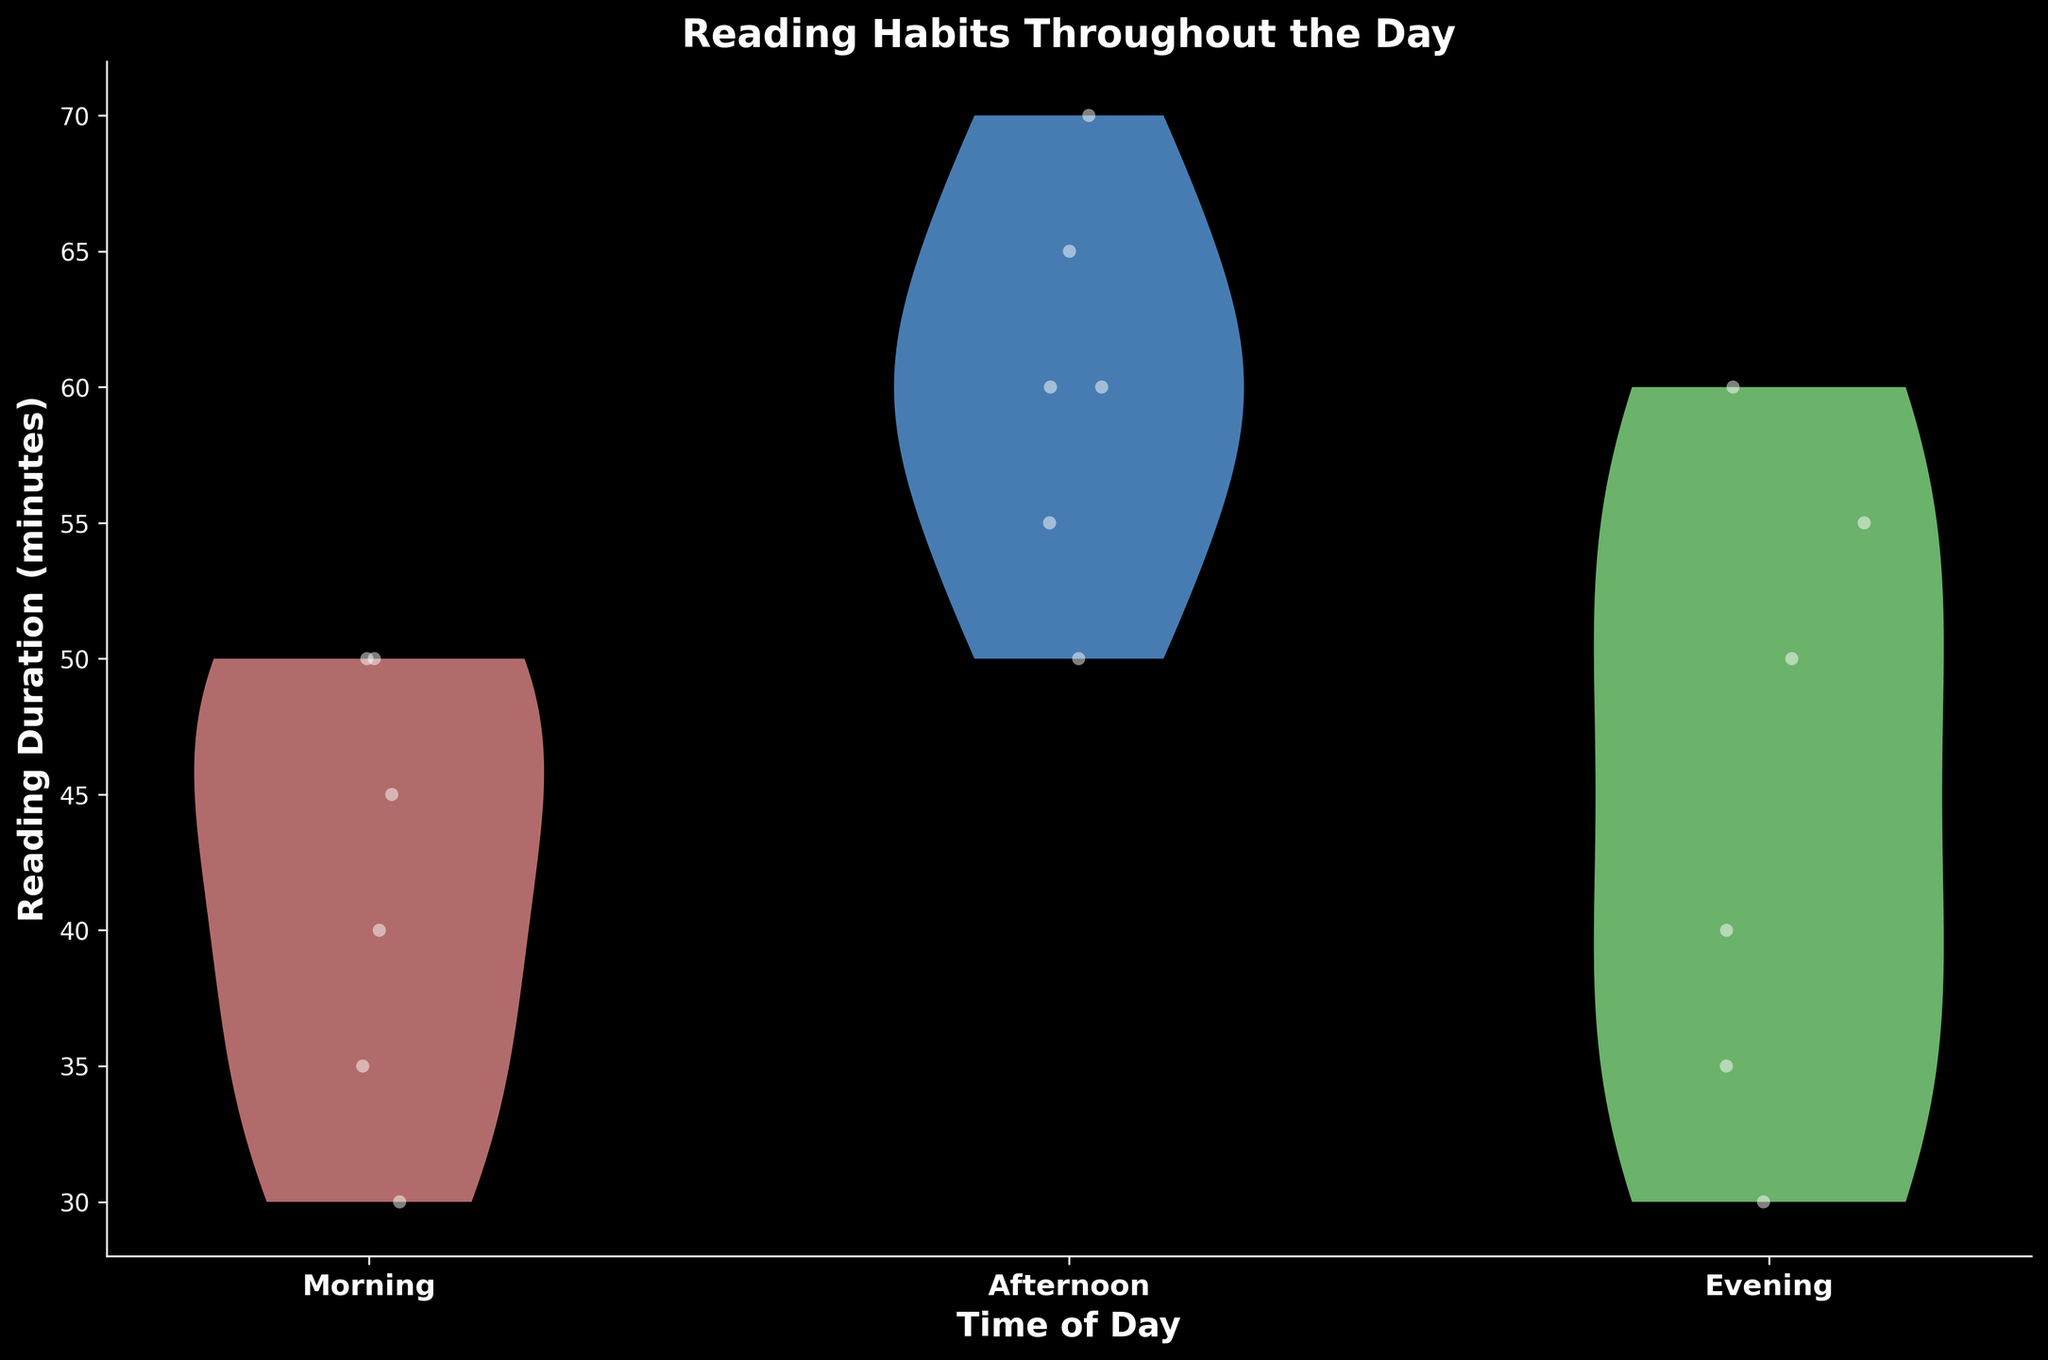What is the title of the figure? The title is usually located at the top of the figure. In this case, it reads 'Reading Habits Throughout the Day'.
Answer: Reading Habits Throughout the Day What are the x-axis labels in the figure? The labels on the x-axis correspond to the time of day, which are 'Morning', 'Afternoon', and 'Evening'.
Answer: Morning, Afternoon, Evening What is the color of the violin plot for the Afternoon time period? The figure uses different colors to distinguish between time periods. The violin plot for the Afternoon is colored light blue.
Answer: Light blue Which time period shows the widest range of reading durations? By comparing the width of the violin plots, we can observe that the Afternoon has the widest range of reading durations.
Answer: Afternoon What is the general trend for reading durations in the Evening compared to Morning? Looking at the overall shape and spread of the violin plots, reading durations in the Evening are generally lower compared to Morning.
Answer: Lower How many data points are visible for the Morning time period? By counting the white points jittered over the violin plot for the Morning, we can determine there are 6 data points.
Answer: 6 Which time period has the highest median reading duration? Examining the spread and central concentration of the violin plots, the Afternoon appears to have the highest median reading duration.
Answer: Afternoon By how many minutes does the longest reading duration in the Evening exceed the shortest reading duration in the Afternoon? The longest reading duration in the Evening is 60 minutes, and the shortest in the Afternoon is 50 minutes. The difference is 60 - 50 = 10 minutes.
Answer: 10 minutes Compare the central concentration of reading durations between Morning and Afternoon. Which period shows a higher concentration towards a specific reading duration? The violin plot for the Afternoon shows a stronger concentration around 60 minutes, compared to the Morning's more dispersed durations.
Answer: Afternoon 